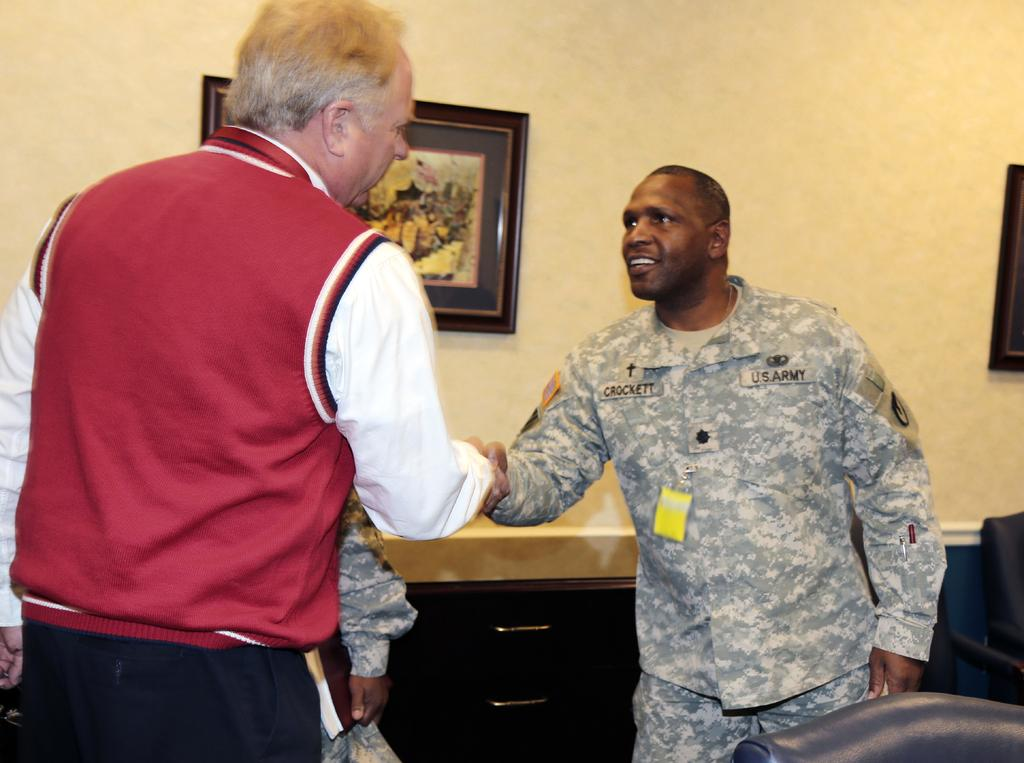How many people are in the image? There are three persons in the image. Where are the persons located in the image? The persons are on the floor and chairs. What can be seen in the background of the image? There is a table and a wall painting on a wall in the background. What type of location might the image have been taken in? The image may have been taken in a hall. What type of zinc object can be seen on the floor in the image? There is no zinc object present on the floor in the image. Can you see any heart-shaped objects in the image? There are no heart-shaped objects visible in the image. 